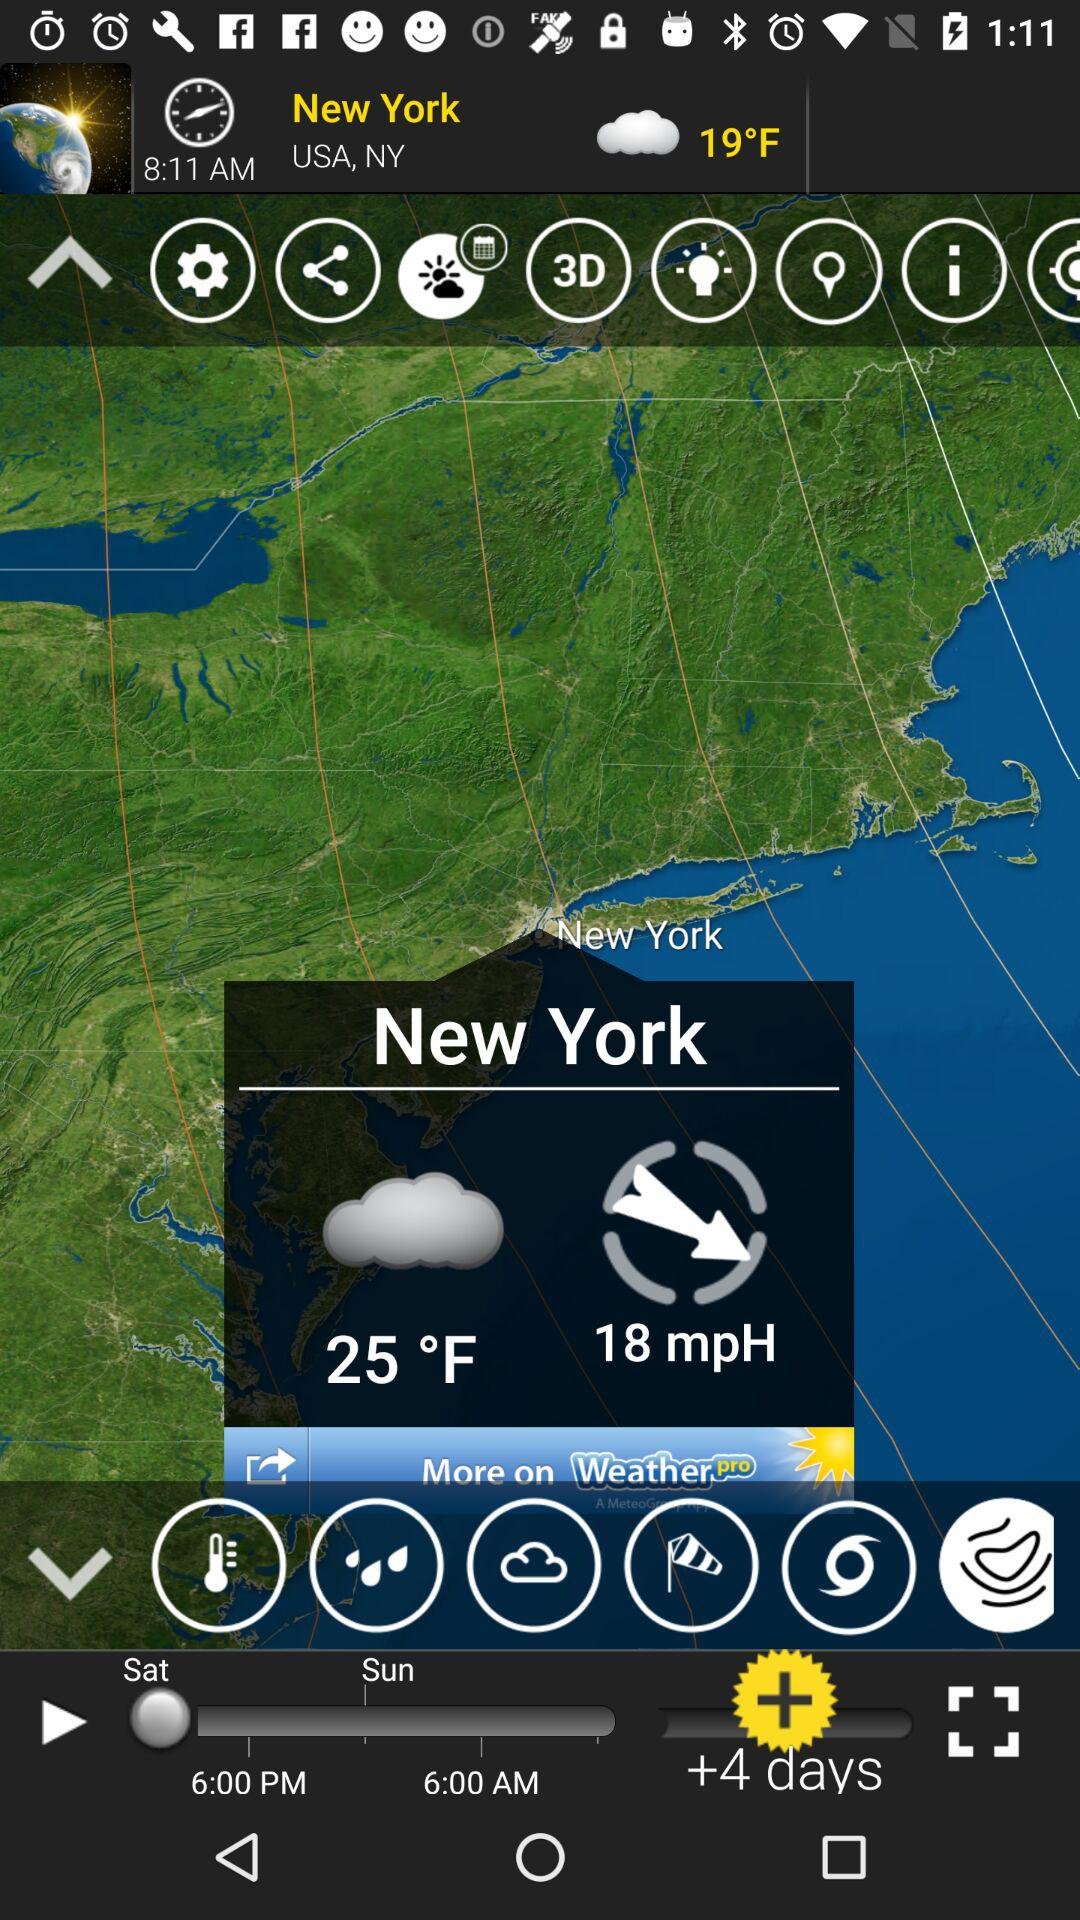What is the time in New York? The time is 8:11 AM. 